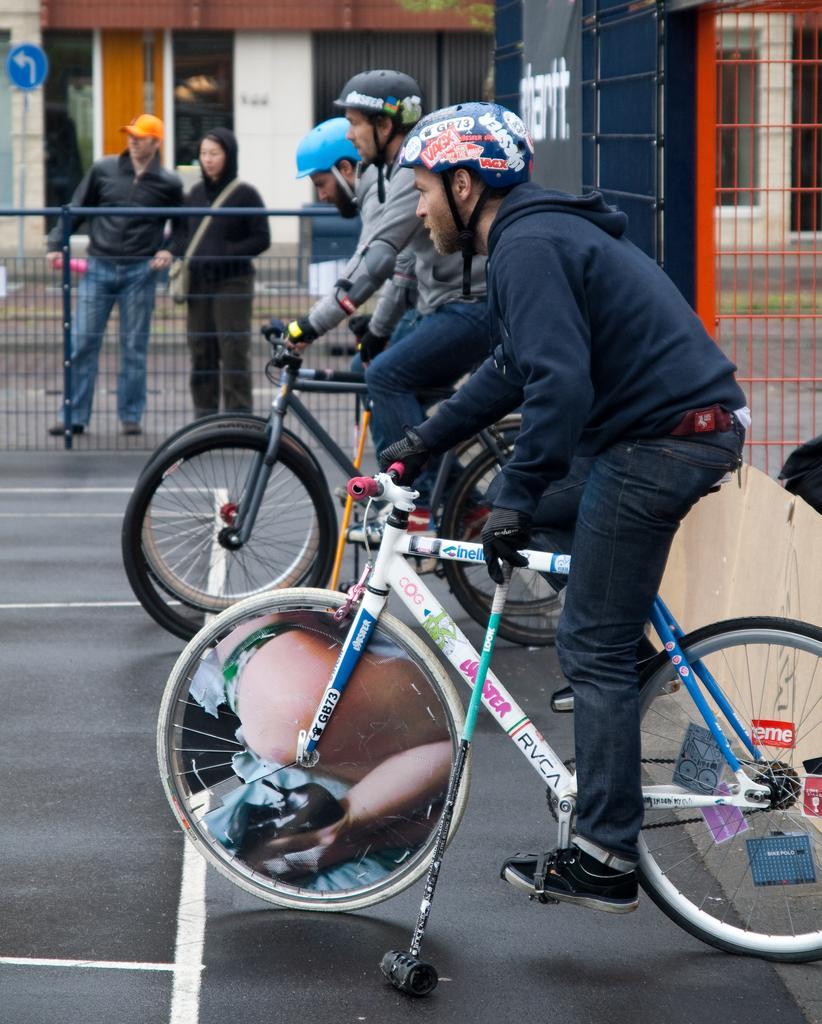Describe this image in one or two sentences. This is an outside view. There are three persons are riding their bicycles. Three persons are wearing different color t-shirts and different color helmets on their heads. On the top left corner of the image I can see two persons are standing. In the background I can see a building. 